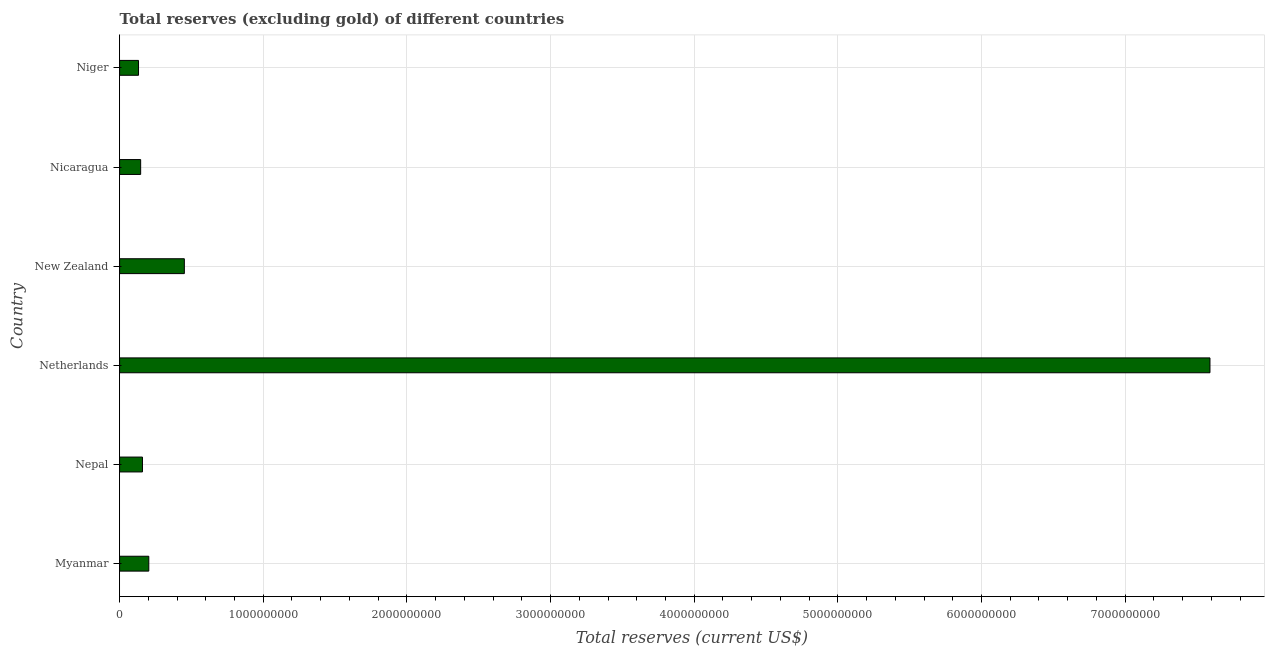Does the graph contain any zero values?
Provide a short and direct response. No. What is the title of the graph?
Offer a very short reply. Total reserves (excluding gold) of different countries. What is the label or title of the X-axis?
Your response must be concise. Total reserves (current US$). What is the label or title of the Y-axis?
Provide a short and direct response. Country. What is the total reserves (excluding gold) in Niger?
Offer a very short reply. 1.32e+08. Across all countries, what is the maximum total reserves (excluding gold)?
Your response must be concise. 7.59e+09. Across all countries, what is the minimum total reserves (excluding gold)?
Your answer should be compact. 1.32e+08. In which country was the total reserves (excluding gold) minimum?
Offer a terse response. Niger. What is the sum of the total reserves (excluding gold)?
Provide a succinct answer. 8.68e+09. What is the difference between the total reserves (excluding gold) in Nicaragua and Niger?
Your answer should be compact. 1.49e+07. What is the average total reserves (excluding gold) per country?
Keep it short and to the point. 1.45e+09. What is the median total reserves (excluding gold)?
Make the answer very short. 1.81e+08. In how many countries, is the total reserves (excluding gold) greater than 1800000000 US$?
Provide a short and direct response. 1. What is the ratio of the total reserves (excluding gold) in Netherlands to that in Nicaragua?
Make the answer very short. 51.77. Is the total reserves (excluding gold) in Myanmar less than that in Nicaragua?
Provide a succinct answer. No. Is the difference between the total reserves (excluding gold) in Netherlands and New Zealand greater than the difference between any two countries?
Give a very brief answer. No. What is the difference between the highest and the second highest total reserves (excluding gold)?
Your answer should be compact. 7.14e+09. What is the difference between the highest and the lowest total reserves (excluding gold)?
Ensure brevity in your answer.  7.46e+09. In how many countries, is the total reserves (excluding gold) greater than the average total reserves (excluding gold) taken over all countries?
Keep it short and to the point. 1. Are the values on the major ticks of X-axis written in scientific E-notation?
Provide a succinct answer. No. What is the Total reserves (current US$) in Myanmar?
Your answer should be very brief. 2.03e+08. What is the Total reserves (current US$) of Nepal?
Your response must be concise. 1.59e+08. What is the Total reserves (current US$) in Netherlands?
Your response must be concise. 7.59e+09. What is the Total reserves (current US$) in New Zealand?
Provide a short and direct response. 4.51e+08. What is the Total reserves (current US$) in Nicaragua?
Your answer should be very brief. 1.47e+08. What is the Total reserves (current US$) in Niger?
Provide a short and direct response. 1.32e+08. What is the difference between the Total reserves (current US$) in Myanmar and Nepal?
Provide a short and direct response. 4.41e+07. What is the difference between the Total reserves (current US$) in Myanmar and Netherlands?
Offer a very short reply. -7.39e+09. What is the difference between the Total reserves (current US$) in Myanmar and New Zealand?
Ensure brevity in your answer.  -2.47e+08. What is the difference between the Total reserves (current US$) in Myanmar and Nicaragua?
Ensure brevity in your answer.  5.66e+07. What is the difference between the Total reserves (current US$) in Myanmar and Niger?
Your answer should be very brief. 7.16e+07. What is the difference between the Total reserves (current US$) in Nepal and Netherlands?
Offer a terse response. -7.43e+09. What is the difference between the Total reserves (current US$) in Nepal and New Zealand?
Ensure brevity in your answer.  -2.92e+08. What is the difference between the Total reserves (current US$) in Nepal and Nicaragua?
Give a very brief answer. 1.25e+07. What is the difference between the Total reserves (current US$) in Nepal and Niger?
Your answer should be very brief. 2.75e+07. What is the difference between the Total reserves (current US$) in Netherlands and New Zealand?
Give a very brief answer. 7.14e+09. What is the difference between the Total reserves (current US$) in Netherlands and Nicaragua?
Make the answer very short. 7.44e+09. What is the difference between the Total reserves (current US$) in Netherlands and Niger?
Provide a succinct answer. 7.46e+09. What is the difference between the Total reserves (current US$) in New Zealand and Nicaragua?
Provide a succinct answer. 3.04e+08. What is the difference between the Total reserves (current US$) in New Zealand and Niger?
Provide a short and direct response. 3.19e+08. What is the difference between the Total reserves (current US$) in Nicaragua and Niger?
Offer a terse response. 1.49e+07. What is the ratio of the Total reserves (current US$) in Myanmar to that in Nepal?
Ensure brevity in your answer.  1.28. What is the ratio of the Total reserves (current US$) in Myanmar to that in Netherlands?
Your answer should be compact. 0.03. What is the ratio of the Total reserves (current US$) in Myanmar to that in New Zealand?
Offer a terse response. 0.45. What is the ratio of the Total reserves (current US$) in Myanmar to that in Nicaragua?
Offer a terse response. 1.39. What is the ratio of the Total reserves (current US$) in Myanmar to that in Niger?
Provide a succinct answer. 1.54. What is the ratio of the Total reserves (current US$) in Nepal to that in Netherlands?
Your answer should be very brief. 0.02. What is the ratio of the Total reserves (current US$) in Nepal to that in New Zealand?
Your answer should be compact. 0.35. What is the ratio of the Total reserves (current US$) in Nepal to that in Nicaragua?
Provide a succinct answer. 1.09. What is the ratio of the Total reserves (current US$) in Nepal to that in Niger?
Keep it short and to the point. 1.21. What is the ratio of the Total reserves (current US$) in Netherlands to that in New Zealand?
Your response must be concise. 16.84. What is the ratio of the Total reserves (current US$) in Netherlands to that in Nicaragua?
Ensure brevity in your answer.  51.77. What is the ratio of the Total reserves (current US$) in Netherlands to that in Niger?
Your answer should be very brief. 57.64. What is the ratio of the Total reserves (current US$) in New Zealand to that in Nicaragua?
Your answer should be compact. 3.07. What is the ratio of the Total reserves (current US$) in New Zealand to that in Niger?
Keep it short and to the point. 3.42. What is the ratio of the Total reserves (current US$) in Nicaragua to that in Niger?
Provide a short and direct response. 1.11. 